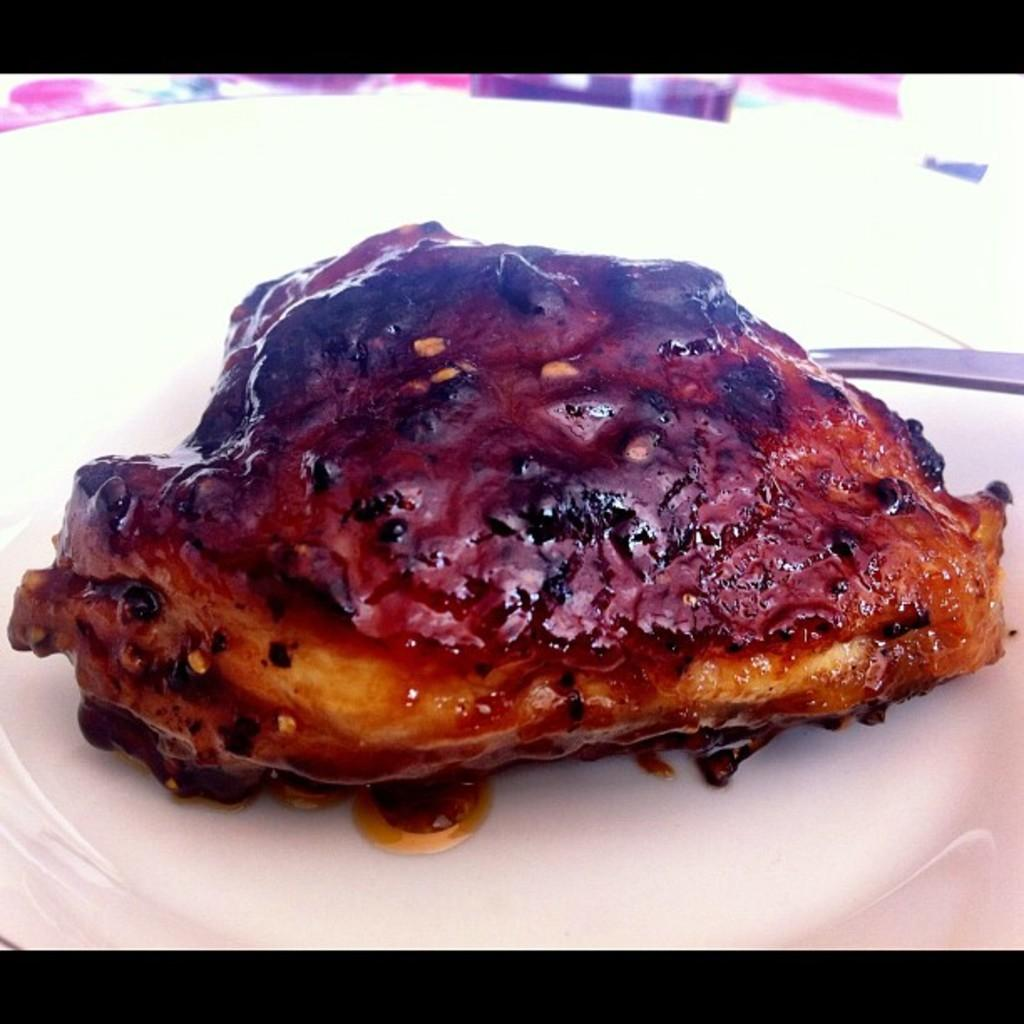What is on the plate in the image? There is a spoon and an edible item on the plate in the image. What color is the plate? The plate is white. What colors can be seen in the background of the image? The background of the image has white, pink, and blue colors. What colors are present at the top and bottom of the image? The top and bottom of the image are black in color. What type of treatment is being administered to the cake in the image? There is no cake present in the image, and therefore no treatment can be administered to it. 